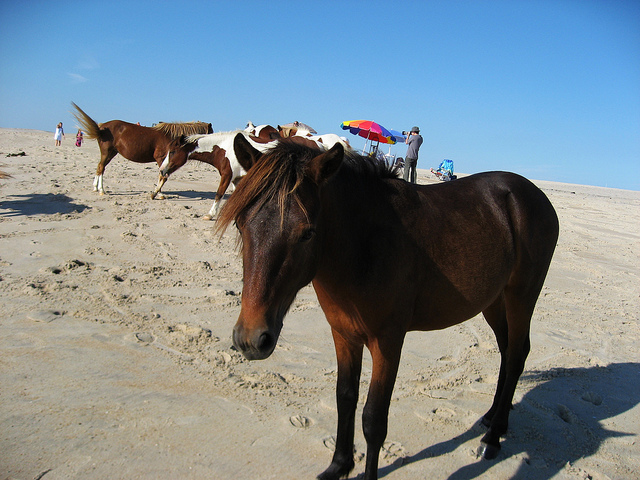How many horses are countable on the beach?
A. three
B. five
C. four
D. two Option B. Five horses are visible on the beach, each enjoying the sun and the sand in their own way. Their relaxed postures suggest they are accustomed to their beachside habitat, coexisting peacefully with the visitors in the background under the colorful umbrella. 